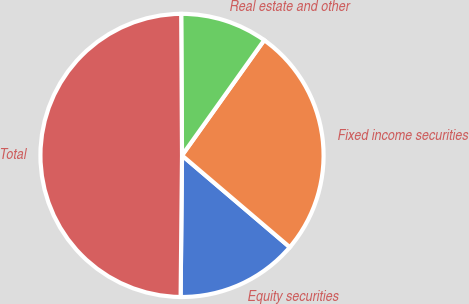Convert chart. <chart><loc_0><loc_0><loc_500><loc_500><pie_chart><fcel>Equity securities<fcel>Fixed income securities<fcel>Real estate and other<fcel>Total<nl><fcel>13.93%<fcel>26.37%<fcel>9.95%<fcel>49.75%<nl></chart> 